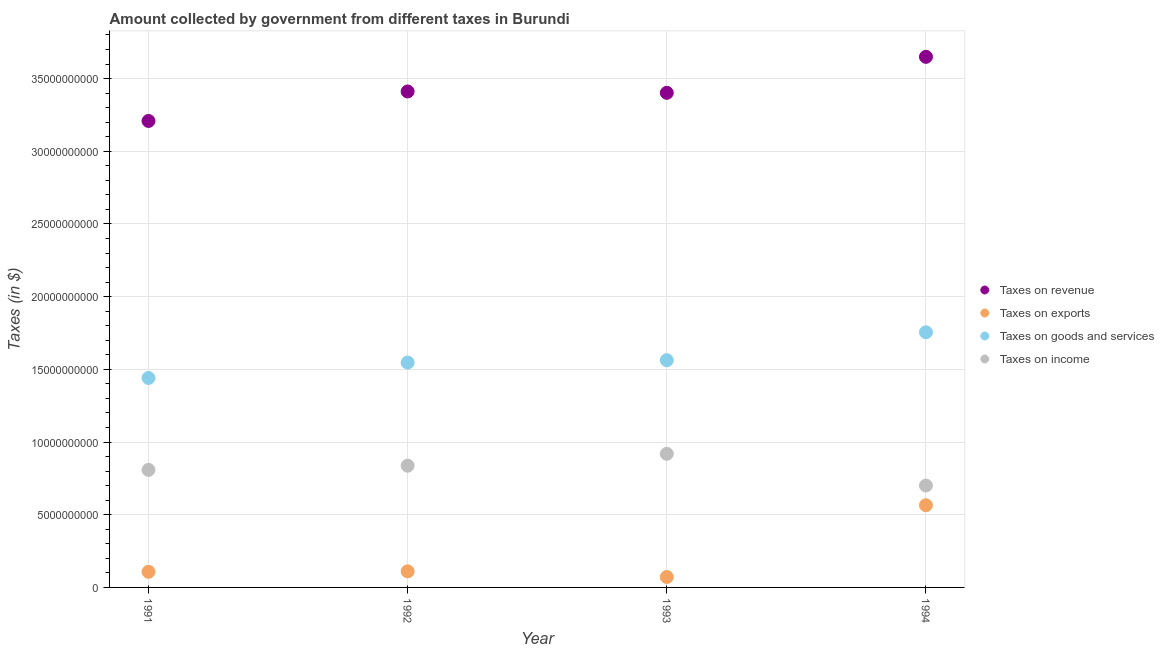How many different coloured dotlines are there?
Provide a short and direct response. 4. Is the number of dotlines equal to the number of legend labels?
Provide a short and direct response. Yes. What is the amount collected as tax on goods in 1993?
Keep it short and to the point. 1.56e+1. Across all years, what is the maximum amount collected as tax on revenue?
Your answer should be very brief. 3.65e+1. Across all years, what is the minimum amount collected as tax on exports?
Offer a terse response. 7.16e+08. What is the total amount collected as tax on income in the graph?
Offer a terse response. 3.27e+1. What is the difference between the amount collected as tax on revenue in 1992 and that in 1993?
Your answer should be compact. 9.40e+07. What is the difference between the amount collected as tax on income in 1992 and the amount collected as tax on exports in 1991?
Ensure brevity in your answer.  7.30e+09. What is the average amount collected as tax on income per year?
Your answer should be very brief. 8.16e+09. In the year 1994, what is the difference between the amount collected as tax on exports and amount collected as tax on goods?
Your answer should be compact. -1.19e+1. In how many years, is the amount collected as tax on exports greater than 36000000000 $?
Provide a succinct answer. 0. What is the ratio of the amount collected as tax on income in 1991 to that in 1993?
Keep it short and to the point. 0.88. Is the amount collected as tax on exports in 1991 less than that in 1994?
Your answer should be very brief. Yes. Is the difference between the amount collected as tax on income in 1992 and 1993 greater than the difference between the amount collected as tax on revenue in 1992 and 1993?
Give a very brief answer. No. What is the difference between the highest and the second highest amount collected as tax on goods?
Offer a terse response. 1.92e+09. What is the difference between the highest and the lowest amount collected as tax on goods?
Your answer should be compact. 3.14e+09. Is it the case that in every year, the sum of the amount collected as tax on revenue and amount collected as tax on exports is greater than the amount collected as tax on goods?
Your response must be concise. Yes. Does the amount collected as tax on goods monotonically increase over the years?
Keep it short and to the point. Yes. How many dotlines are there?
Provide a succinct answer. 4. How many years are there in the graph?
Provide a short and direct response. 4. Are the values on the major ticks of Y-axis written in scientific E-notation?
Give a very brief answer. No. Does the graph contain grids?
Offer a terse response. Yes. Where does the legend appear in the graph?
Provide a short and direct response. Center right. How many legend labels are there?
Offer a terse response. 4. How are the legend labels stacked?
Ensure brevity in your answer.  Vertical. What is the title of the graph?
Provide a succinct answer. Amount collected by government from different taxes in Burundi. What is the label or title of the X-axis?
Your answer should be very brief. Year. What is the label or title of the Y-axis?
Provide a succinct answer. Taxes (in $). What is the Taxes (in $) of Taxes on revenue in 1991?
Offer a very short reply. 3.21e+1. What is the Taxes (in $) in Taxes on exports in 1991?
Offer a very short reply. 1.07e+09. What is the Taxes (in $) of Taxes on goods and services in 1991?
Ensure brevity in your answer.  1.44e+1. What is the Taxes (in $) of Taxes on income in 1991?
Offer a very short reply. 8.08e+09. What is the Taxes (in $) of Taxes on revenue in 1992?
Give a very brief answer. 3.41e+1. What is the Taxes (in $) of Taxes on exports in 1992?
Ensure brevity in your answer.  1.11e+09. What is the Taxes (in $) in Taxes on goods and services in 1992?
Provide a short and direct response. 1.55e+1. What is the Taxes (in $) of Taxes on income in 1992?
Offer a terse response. 8.37e+09. What is the Taxes (in $) in Taxes on revenue in 1993?
Your response must be concise. 3.40e+1. What is the Taxes (in $) in Taxes on exports in 1993?
Keep it short and to the point. 7.16e+08. What is the Taxes (in $) of Taxes on goods and services in 1993?
Your answer should be very brief. 1.56e+1. What is the Taxes (in $) in Taxes on income in 1993?
Offer a very short reply. 9.19e+09. What is the Taxes (in $) of Taxes on revenue in 1994?
Provide a short and direct response. 3.65e+1. What is the Taxes (in $) in Taxes on exports in 1994?
Make the answer very short. 5.65e+09. What is the Taxes (in $) of Taxes on goods and services in 1994?
Your answer should be very brief. 1.76e+1. What is the Taxes (in $) in Taxes on income in 1994?
Your answer should be compact. 7.01e+09. Across all years, what is the maximum Taxes (in $) of Taxes on revenue?
Offer a very short reply. 3.65e+1. Across all years, what is the maximum Taxes (in $) of Taxes on exports?
Ensure brevity in your answer.  5.65e+09. Across all years, what is the maximum Taxes (in $) in Taxes on goods and services?
Provide a short and direct response. 1.76e+1. Across all years, what is the maximum Taxes (in $) of Taxes on income?
Your answer should be compact. 9.19e+09. Across all years, what is the minimum Taxes (in $) in Taxes on revenue?
Offer a terse response. 3.21e+1. Across all years, what is the minimum Taxes (in $) of Taxes on exports?
Provide a succinct answer. 7.16e+08. Across all years, what is the minimum Taxes (in $) of Taxes on goods and services?
Ensure brevity in your answer.  1.44e+1. Across all years, what is the minimum Taxes (in $) in Taxes on income?
Provide a succinct answer. 7.01e+09. What is the total Taxes (in $) of Taxes on revenue in the graph?
Give a very brief answer. 1.37e+11. What is the total Taxes (in $) of Taxes on exports in the graph?
Offer a terse response. 8.55e+09. What is the total Taxes (in $) of Taxes on goods and services in the graph?
Ensure brevity in your answer.  6.31e+1. What is the total Taxes (in $) of Taxes on income in the graph?
Ensure brevity in your answer.  3.27e+1. What is the difference between the Taxes (in $) in Taxes on revenue in 1991 and that in 1992?
Your response must be concise. -2.03e+09. What is the difference between the Taxes (in $) in Taxes on exports in 1991 and that in 1992?
Ensure brevity in your answer.  -3.20e+07. What is the difference between the Taxes (in $) of Taxes on goods and services in 1991 and that in 1992?
Offer a very short reply. -1.06e+09. What is the difference between the Taxes (in $) of Taxes on income in 1991 and that in 1992?
Provide a short and direct response. -2.89e+08. What is the difference between the Taxes (in $) of Taxes on revenue in 1991 and that in 1993?
Make the answer very short. -1.94e+09. What is the difference between the Taxes (in $) of Taxes on exports in 1991 and that in 1993?
Offer a very short reply. 3.58e+08. What is the difference between the Taxes (in $) of Taxes on goods and services in 1991 and that in 1993?
Keep it short and to the point. -1.22e+09. What is the difference between the Taxes (in $) of Taxes on income in 1991 and that in 1993?
Make the answer very short. -1.11e+09. What is the difference between the Taxes (in $) in Taxes on revenue in 1991 and that in 1994?
Provide a short and direct response. -4.41e+09. What is the difference between the Taxes (in $) in Taxes on exports in 1991 and that in 1994?
Your answer should be very brief. -4.58e+09. What is the difference between the Taxes (in $) of Taxes on goods and services in 1991 and that in 1994?
Ensure brevity in your answer.  -3.14e+09. What is the difference between the Taxes (in $) in Taxes on income in 1991 and that in 1994?
Your answer should be compact. 1.08e+09. What is the difference between the Taxes (in $) in Taxes on revenue in 1992 and that in 1993?
Offer a very short reply. 9.40e+07. What is the difference between the Taxes (in $) of Taxes on exports in 1992 and that in 1993?
Your answer should be compact. 3.90e+08. What is the difference between the Taxes (in $) in Taxes on goods and services in 1992 and that in 1993?
Provide a succinct answer. -1.65e+08. What is the difference between the Taxes (in $) in Taxes on income in 1992 and that in 1993?
Your response must be concise. -8.18e+08. What is the difference between the Taxes (in $) in Taxes on revenue in 1992 and that in 1994?
Make the answer very short. -2.38e+09. What is the difference between the Taxes (in $) of Taxes on exports in 1992 and that in 1994?
Offer a very short reply. -4.55e+09. What is the difference between the Taxes (in $) of Taxes on goods and services in 1992 and that in 1994?
Your response must be concise. -2.08e+09. What is the difference between the Taxes (in $) of Taxes on income in 1992 and that in 1994?
Keep it short and to the point. 1.36e+09. What is the difference between the Taxes (in $) of Taxes on revenue in 1993 and that in 1994?
Your answer should be very brief. -2.48e+09. What is the difference between the Taxes (in $) of Taxes on exports in 1993 and that in 1994?
Your answer should be very brief. -4.94e+09. What is the difference between the Taxes (in $) of Taxes on goods and services in 1993 and that in 1994?
Provide a short and direct response. -1.92e+09. What is the difference between the Taxes (in $) of Taxes on income in 1993 and that in 1994?
Give a very brief answer. 2.18e+09. What is the difference between the Taxes (in $) in Taxes on revenue in 1991 and the Taxes (in $) in Taxes on exports in 1992?
Your answer should be very brief. 3.10e+1. What is the difference between the Taxes (in $) in Taxes on revenue in 1991 and the Taxes (in $) in Taxes on goods and services in 1992?
Offer a terse response. 1.66e+1. What is the difference between the Taxes (in $) of Taxes on revenue in 1991 and the Taxes (in $) of Taxes on income in 1992?
Provide a succinct answer. 2.37e+1. What is the difference between the Taxes (in $) in Taxes on exports in 1991 and the Taxes (in $) in Taxes on goods and services in 1992?
Ensure brevity in your answer.  -1.44e+1. What is the difference between the Taxes (in $) in Taxes on exports in 1991 and the Taxes (in $) in Taxes on income in 1992?
Provide a short and direct response. -7.30e+09. What is the difference between the Taxes (in $) of Taxes on goods and services in 1991 and the Taxes (in $) of Taxes on income in 1992?
Your answer should be very brief. 6.03e+09. What is the difference between the Taxes (in $) in Taxes on revenue in 1991 and the Taxes (in $) in Taxes on exports in 1993?
Provide a short and direct response. 3.14e+1. What is the difference between the Taxes (in $) in Taxes on revenue in 1991 and the Taxes (in $) in Taxes on goods and services in 1993?
Your response must be concise. 1.65e+1. What is the difference between the Taxes (in $) in Taxes on revenue in 1991 and the Taxes (in $) in Taxes on income in 1993?
Your answer should be very brief. 2.29e+1. What is the difference between the Taxes (in $) in Taxes on exports in 1991 and the Taxes (in $) in Taxes on goods and services in 1993?
Give a very brief answer. -1.46e+1. What is the difference between the Taxes (in $) of Taxes on exports in 1991 and the Taxes (in $) of Taxes on income in 1993?
Your answer should be compact. -8.12e+09. What is the difference between the Taxes (in $) of Taxes on goods and services in 1991 and the Taxes (in $) of Taxes on income in 1993?
Give a very brief answer. 5.22e+09. What is the difference between the Taxes (in $) of Taxes on revenue in 1991 and the Taxes (in $) of Taxes on exports in 1994?
Provide a short and direct response. 2.64e+1. What is the difference between the Taxes (in $) in Taxes on revenue in 1991 and the Taxes (in $) in Taxes on goods and services in 1994?
Give a very brief answer. 1.45e+1. What is the difference between the Taxes (in $) of Taxes on revenue in 1991 and the Taxes (in $) of Taxes on income in 1994?
Offer a very short reply. 2.51e+1. What is the difference between the Taxes (in $) of Taxes on exports in 1991 and the Taxes (in $) of Taxes on goods and services in 1994?
Your response must be concise. -1.65e+1. What is the difference between the Taxes (in $) in Taxes on exports in 1991 and the Taxes (in $) in Taxes on income in 1994?
Provide a succinct answer. -5.94e+09. What is the difference between the Taxes (in $) of Taxes on goods and services in 1991 and the Taxes (in $) of Taxes on income in 1994?
Give a very brief answer. 7.40e+09. What is the difference between the Taxes (in $) in Taxes on revenue in 1992 and the Taxes (in $) in Taxes on exports in 1993?
Provide a short and direct response. 3.34e+1. What is the difference between the Taxes (in $) of Taxes on revenue in 1992 and the Taxes (in $) of Taxes on goods and services in 1993?
Make the answer very short. 1.85e+1. What is the difference between the Taxes (in $) in Taxes on revenue in 1992 and the Taxes (in $) in Taxes on income in 1993?
Your answer should be very brief. 2.49e+1. What is the difference between the Taxes (in $) of Taxes on exports in 1992 and the Taxes (in $) of Taxes on goods and services in 1993?
Make the answer very short. -1.45e+1. What is the difference between the Taxes (in $) in Taxes on exports in 1992 and the Taxes (in $) in Taxes on income in 1993?
Provide a short and direct response. -8.09e+09. What is the difference between the Taxes (in $) of Taxes on goods and services in 1992 and the Taxes (in $) of Taxes on income in 1993?
Your answer should be compact. 6.28e+09. What is the difference between the Taxes (in $) of Taxes on revenue in 1992 and the Taxes (in $) of Taxes on exports in 1994?
Your response must be concise. 2.85e+1. What is the difference between the Taxes (in $) in Taxes on revenue in 1992 and the Taxes (in $) in Taxes on goods and services in 1994?
Your answer should be very brief. 1.66e+1. What is the difference between the Taxes (in $) of Taxes on revenue in 1992 and the Taxes (in $) of Taxes on income in 1994?
Keep it short and to the point. 2.71e+1. What is the difference between the Taxes (in $) in Taxes on exports in 1992 and the Taxes (in $) in Taxes on goods and services in 1994?
Make the answer very short. -1.64e+1. What is the difference between the Taxes (in $) of Taxes on exports in 1992 and the Taxes (in $) of Taxes on income in 1994?
Make the answer very short. -5.90e+09. What is the difference between the Taxes (in $) of Taxes on goods and services in 1992 and the Taxes (in $) of Taxes on income in 1994?
Offer a terse response. 8.46e+09. What is the difference between the Taxes (in $) in Taxes on revenue in 1993 and the Taxes (in $) in Taxes on exports in 1994?
Ensure brevity in your answer.  2.84e+1. What is the difference between the Taxes (in $) of Taxes on revenue in 1993 and the Taxes (in $) of Taxes on goods and services in 1994?
Make the answer very short. 1.65e+1. What is the difference between the Taxes (in $) in Taxes on revenue in 1993 and the Taxes (in $) in Taxes on income in 1994?
Keep it short and to the point. 2.70e+1. What is the difference between the Taxes (in $) in Taxes on exports in 1993 and the Taxes (in $) in Taxes on goods and services in 1994?
Your answer should be compact. -1.68e+1. What is the difference between the Taxes (in $) of Taxes on exports in 1993 and the Taxes (in $) of Taxes on income in 1994?
Your response must be concise. -6.29e+09. What is the difference between the Taxes (in $) in Taxes on goods and services in 1993 and the Taxes (in $) in Taxes on income in 1994?
Your answer should be compact. 8.62e+09. What is the average Taxes (in $) of Taxes on revenue per year?
Ensure brevity in your answer.  3.42e+1. What is the average Taxes (in $) in Taxes on exports per year?
Keep it short and to the point. 2.14e+09. What is the average Taxes (in $) in Taxes on goods and services per year?
Keep it short and to the point. 1.58e+1. What is the average Taxes (in $) in Taxes on income per year?
Provide a succinct answer. 8.16e+09. In the year 1991, what is the difference between the Taxes (in $) in Taxes on revenue and Taxes (in $) in Taxes on exports?
Offer a terse response. 3.10e+1. In the year 1991, what is the difference between the Taxes (in $) in Taxes on revenue and Taxes (in $) in Taxes on goods and services?
Offer a terse response. 1.77e+1. In the year 1991, what is the difference between the Taxes (in $) in Taxes on revenue and Taxes (in $) in Taxes on income?
Offer a terse response. 2.40e+1. In the year 1991, what is the difference between the Taxes (in $) of Taxes on exports and Taxes (in $) of Taxes on goods and services?
Make the answer very short. -1.33e+1. In the year 1991, what is the difference between the Taxes (in $) of Taxes on exports and Taxes (in $) of Taxes on income?
Your answer should be compact. -7.01e+09. In the year 1991, what is the difference between the Taxes (in $) in Taxes on goods and services and Taxes (in $) in Taxes on income?
Offer a terse response. 6.32e+09. In the year 1992, what is the difference between the Taxes (in $) in Taxes on revenue and Taxes (in $) in Taxes on exports?
Provide a short and direct response. 3.30e+1. In the year 1992, what is the difference between the Taxes (in $) in Taxes on revenue and Taxes (in $) in Taxes on goods and services?
Your answer should be very brief. 1.86e+1. In the year 1992, what is the difference between the Taxes (in $) of Taxes on revenue and Taxes (in $) of Taxes on income?
Provide a short and direct response. 2.57e+1. In the year 1992, what is the difference between the Taxes (in $) of Taxes on exports and Taxes (in $) of Taxes on goods and services?
Your answer should be compact. -1.44e+1. In the year 1992, what is the difference between the Taxes (in $) in Taxes on exports and Taxes (in $) in Taxes on income?
Offer a very short reply. -7.27e+09. In the year 1992, what is the difference between the Taxes (in $) of Taxes on goods and services and Taxes (in $) of Taxes on income?
Give a very brief answer. 7.09e+09. In the year 1993, what is the difference between the Taxes (in $) of Taxes on revenue and Taxes (in $) of Taxes on exports?
Provide a succinct answer. 3.33e+1. In the year 1993, what is the difference between the Taxes (in $) of Taxes on revenue and Taxes (in $) of Taxes on goods and services?
Provide a short and direct response. 1.84e+1. In the year 1993, what is the difference between the Taxes (in $) in Taxes on revenue and Taxes (in $) in Taxes on income?
Keep it short and to the point. 2.48e+1. In the year 1993, what is the difference between the Taxes (in $) in Taxes on exports and Taxes (in $) in Taxes on goods and services?
Provide a short and direct response. -1.49e+1. In the year 1993, what is the difference between the Taxes (in $) in Taxes on exports and Taxes (in $) in Taxes on income?
Offer a terse response. -8.48e+09. In the year 1993, what is the difference between the Taxes (in $) of Taxes on goods and services and Taxes (in $) of Taxes on income?
Provide a succinct answer. 6.44e+09. In the year 1994, what is the difference between the Taxes (in $) in Taxes on revenue and Taxes (in $) in Taxes on exports?
Offer a very short reply. 3.08e+1. In the year 1994, what is the difference between the Taxes (in $) in Taxes on revenue and Taxes (in $) in Taxes on goods and services?
Provide a short and direct response. 1.89e+1. In the year 1994, what is the difference between the Taxes (in $) in Taxes on revenue and Taxes (in $) in Taxes on income?
Your answer should be very brief. 2.95e+1. In the year 1994, what is the difference between the Taxes (in $) of Taxes on exports and Taxes (in $) of Taxes on goods and services?
Ensure brevity in your answer.  -1.19e+1. In the year 1994, what is the difference between the Taxes (in $) of Taxes on exports and Taxes (in $) of Taxes on income?
Offer a very short reply. -1.36e+09. In the year 1994, what is the difference between the Taxes (in $) in Taxes on goods and services and Taxes (in $) in Taxes on income?
Your response must be concise. 1.05e+1. What is the ratio of the Taxes (in $) in Taxes on revenue in 1991 to that in 1992?
Provide a short and direct response. 0.94. What is the ratio of the Taxes (in $) of Taxes on exports in 1991 to that in 1992?
Your answer should be very brief. 0.97. What is the ratio of the Taxes (in $) in Taxes on goods and services in 1991 to that in 1992?
Offer a terse response. 0.93. What is the ratio of the Taxes (in $) in Taxes on income in 1991 to that in 1992?
Offer a very short reply. 0.97. What is the ratio of the Taxes (in $) of Taxes on revenue in 1991 to that in 1993?
Keep it short and to the point. 0.94. What is the ratio of the Taxes (in $) in Taxes on exports in 1991 to that in 1993?
Offer a terse response. 1.5. What is the ratio of the Taxes (in $) of Taxes on goods and services in 1991 to that in 1993?
Your answer should be compact. 0.92. What is the ratio of the Taxes (in $) in Taxes on income in 1991 to that in 1993?
Your response must be concise. 0.88. What is the ratio of the Taxes (in $) in Taxes on revenue in 1991 to that in 1994?
Your response must be concise. 0.88. What is the ratio of the Taxes (in $) of Taxes on exports in 1991 to that in 1994?
Give a very brief answer. 0.19. What is the ratio of the Taxes (in $) in Taxes on goods and services in 1991 to that in 1994?
Your response must be concise. 0.82. What is the ratio of the Taxes (in $) of Taxes on income in 1991 to that in 1994?
Provide a succinct answer. 1.15. What is the ratio of the Taxes (in $) in Taxes on exports in 1992 to that in 1993?
Your answer should be compact. 1.54. What is the ratio of the Taxes (in $) in Taxes on income in 1992 to that in 1993?
Keep it short and to the point. 0.91. What is the ratio of the Taxes (in $) of Taxes on revenue in 1992 to that in 1994?
Your answer should be very brief. 0.93. What is the ratio of the Taxes (in $) of Taxes on exports in 1992 to that in 1994?
Provide a succinct answer. 0.2. What is the ratio of the Taxes (in $) in Taxes on goods and services in 1992 to that in 1994?
Ensure brevity in your answer.  0.88. What is the ratio of the Taxes (in $) of Taxes on income in 1992 to that in 1994?
Make the answer very short. 1.19. What is the ratio of the Taxes (in $) in Taxes on revenue in 1993 to that in 1994?
Your answer should be compact. 0.93. What is the ratio of the Taxes (in $) of Taxes on exports in 1993 to that in 1994?
Provide a succinct answer. 0.13. What is the ratio of the Taxes (in $) in Taxes on goods and services in 1993 to that in 1994?
Offer a terse response. 0.89. What is the ratio of the Taxes (in $) of Taxes on income in 1993 to that in 1994?
Your answer should be compact. 1.31. What is the difference between the highest and the second highest Taxes (in $) in Taxes on revenue?
Keep it short and to the point. 2.38e+09. What is the difference between the highest and the second highest Taxes (in $) of Taxes on exports?
Your response must be concise. 4.55e+09. What is the difference between the highest and the second highest Taxes (in $) in Taxes on goods and services?
Your answer should be very brief. 1.92e+09. What is the difference between the highest and the second highest Taxes (in $) in Taxes on income?
Give a very brief answer. 8.18e+08. What is the difference between the highest and the lowest Taxes (in $) of Taxes on revenue?
Provide a succinct answer. 4.41e+09. What is the difference between the highest and the lowest Taxes (in $) in Taxes on exports?
Your answer should be very brief. 4.94e+09. What is the difference between the highest and the lowest Taxes (in $) in Taxes on goods and services?
Give a very brief answer. 3.14e+09. What is the difference between the highest and the lowest Taxes (in $) of Taxes on income?
Ensure brevity in your answer.  2.18e+09. 